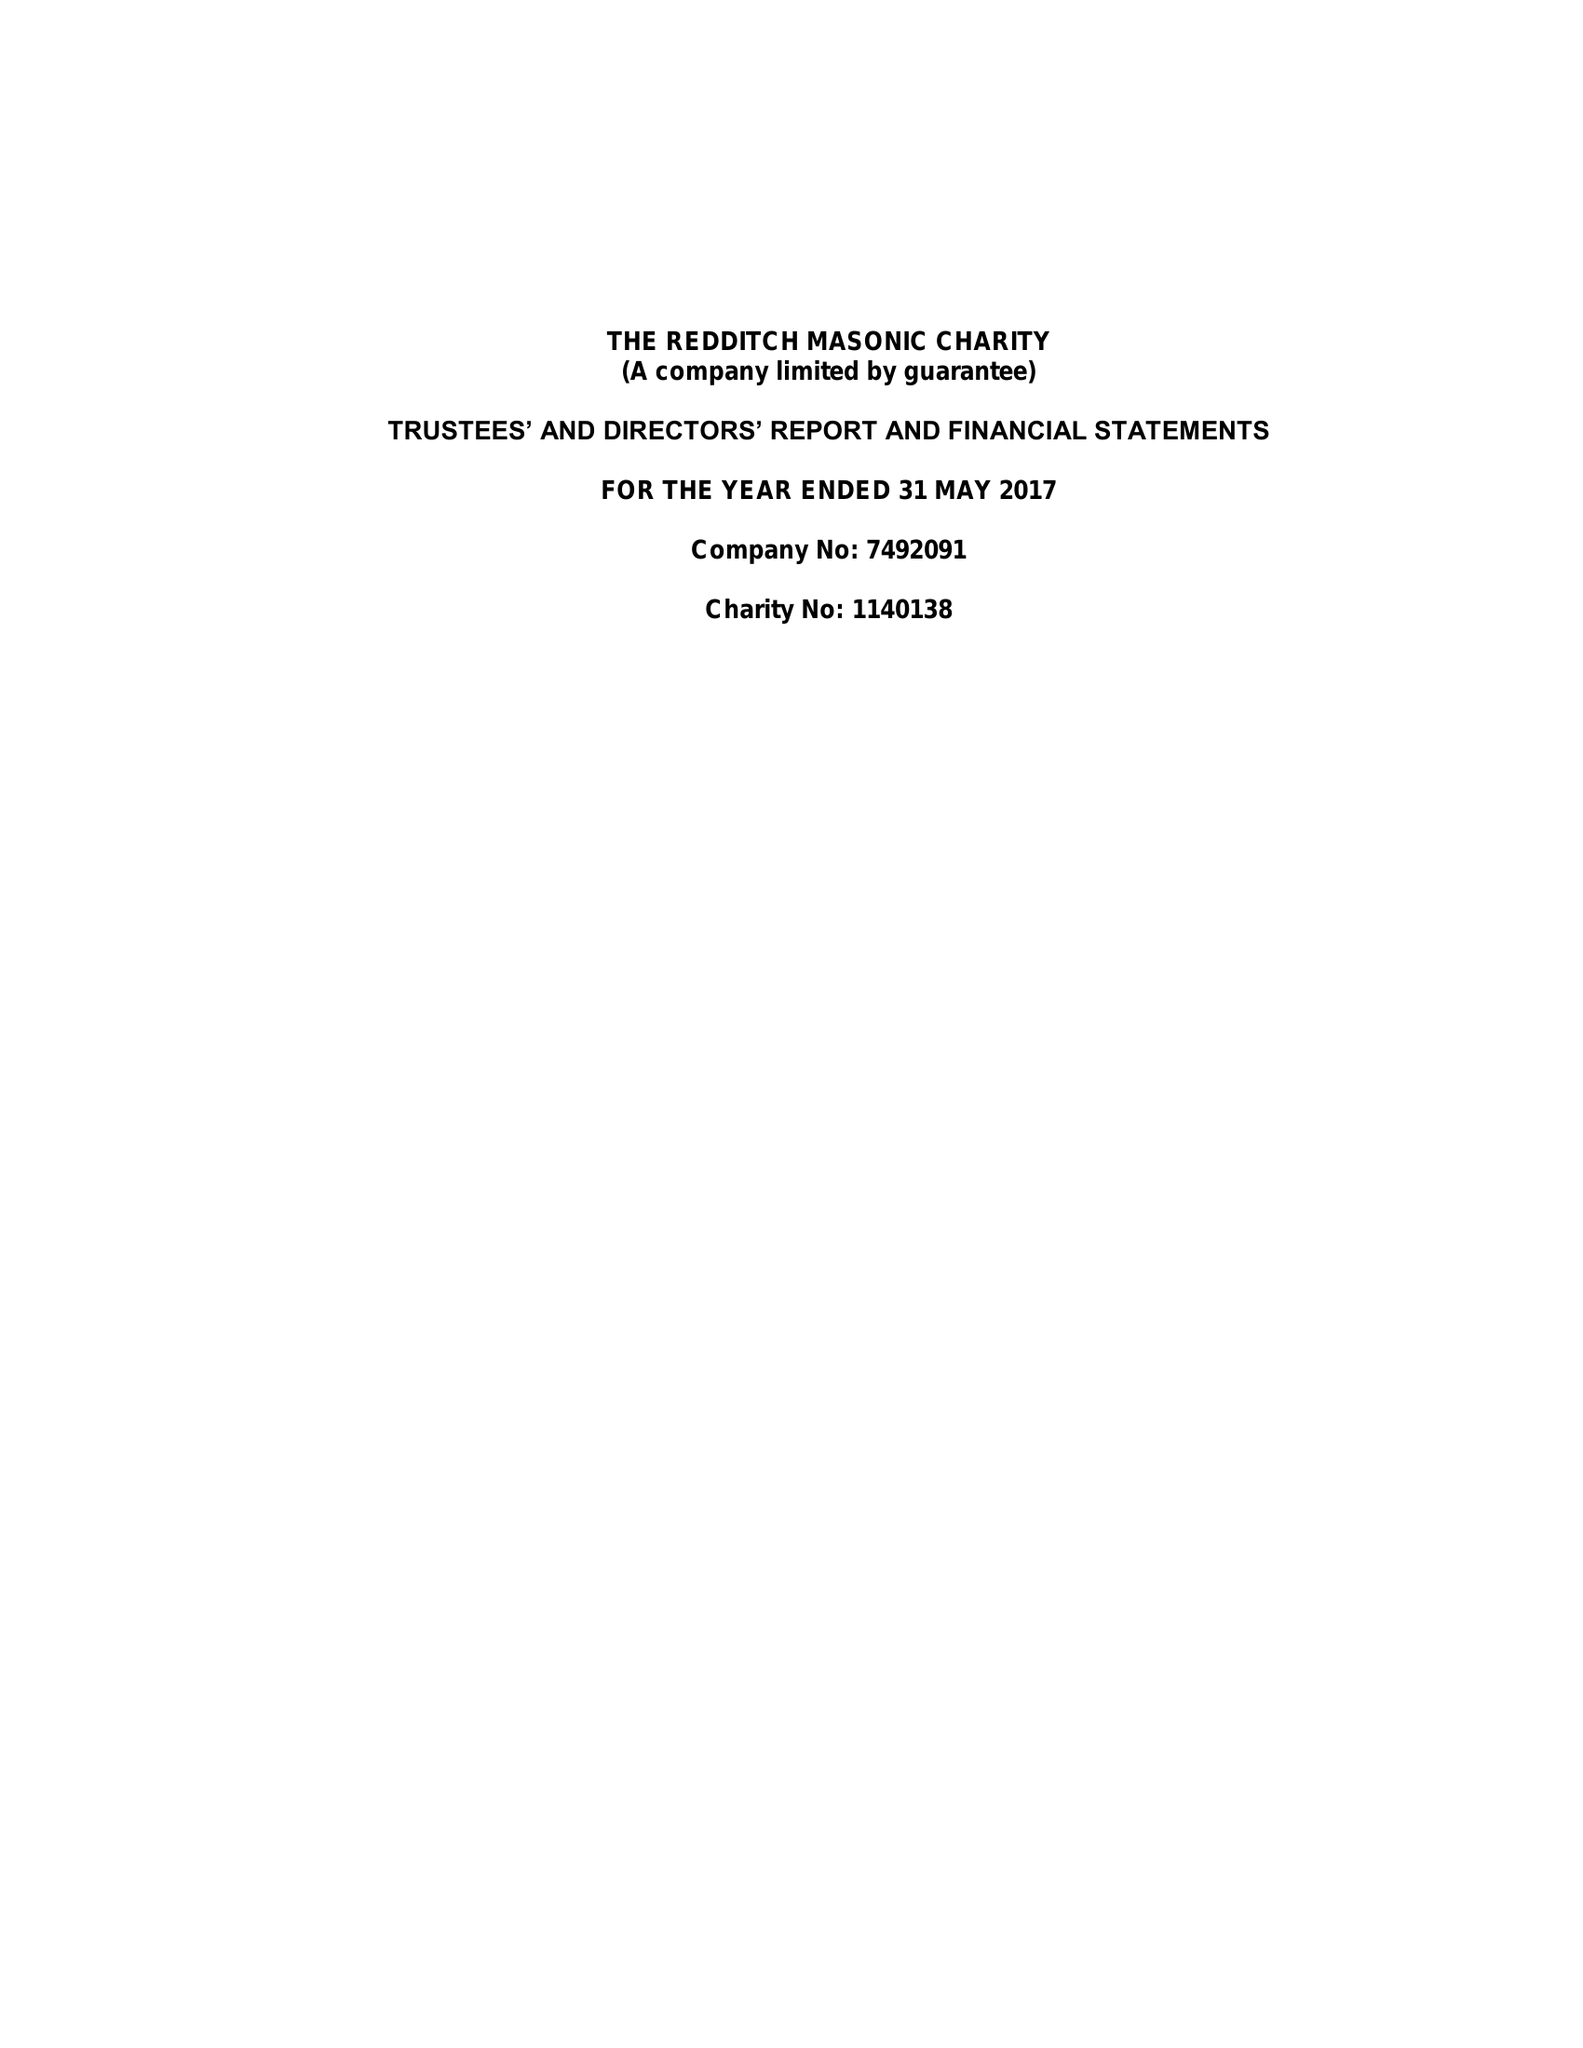What is the value for the charity_name?
Answer the question using a single word or phrase. The Redditch Masonic Charity 